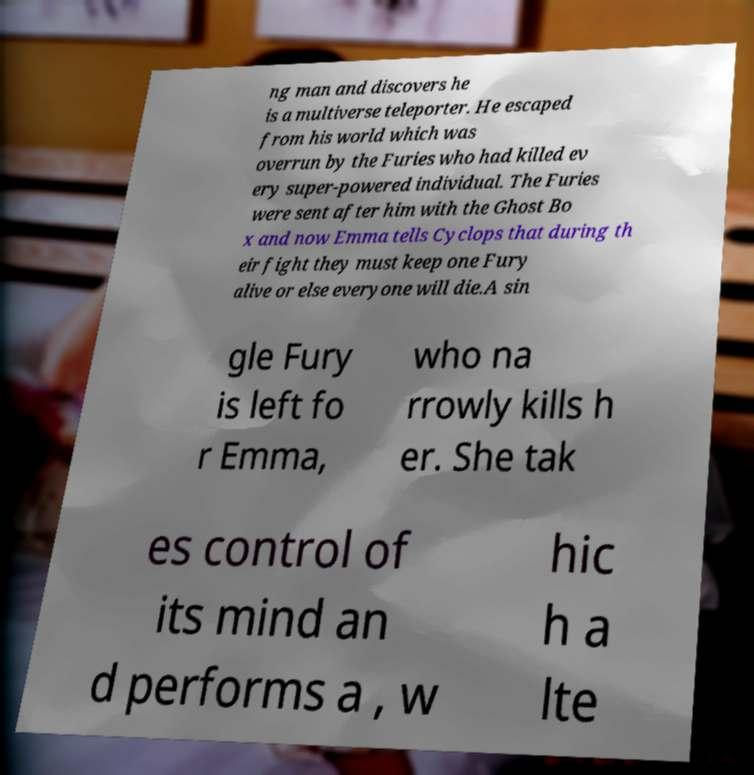Can you accurately transcribe the text from the provided image for me? ng man and discovers he is a multiverse teleporter. He escaped from his world which was overrun by the Furies who had killed ev ery super-powered individual. The Furies were sent after him with the Ghost Bo x and now Emma tells Cyclops that during th eir fight they must keep one Fury alive or else everyone will die.A sin gle Fury is left fo r Emma, who na rrowly kills h er. She tak es control of its mind an d performs a , w hic h a lte 